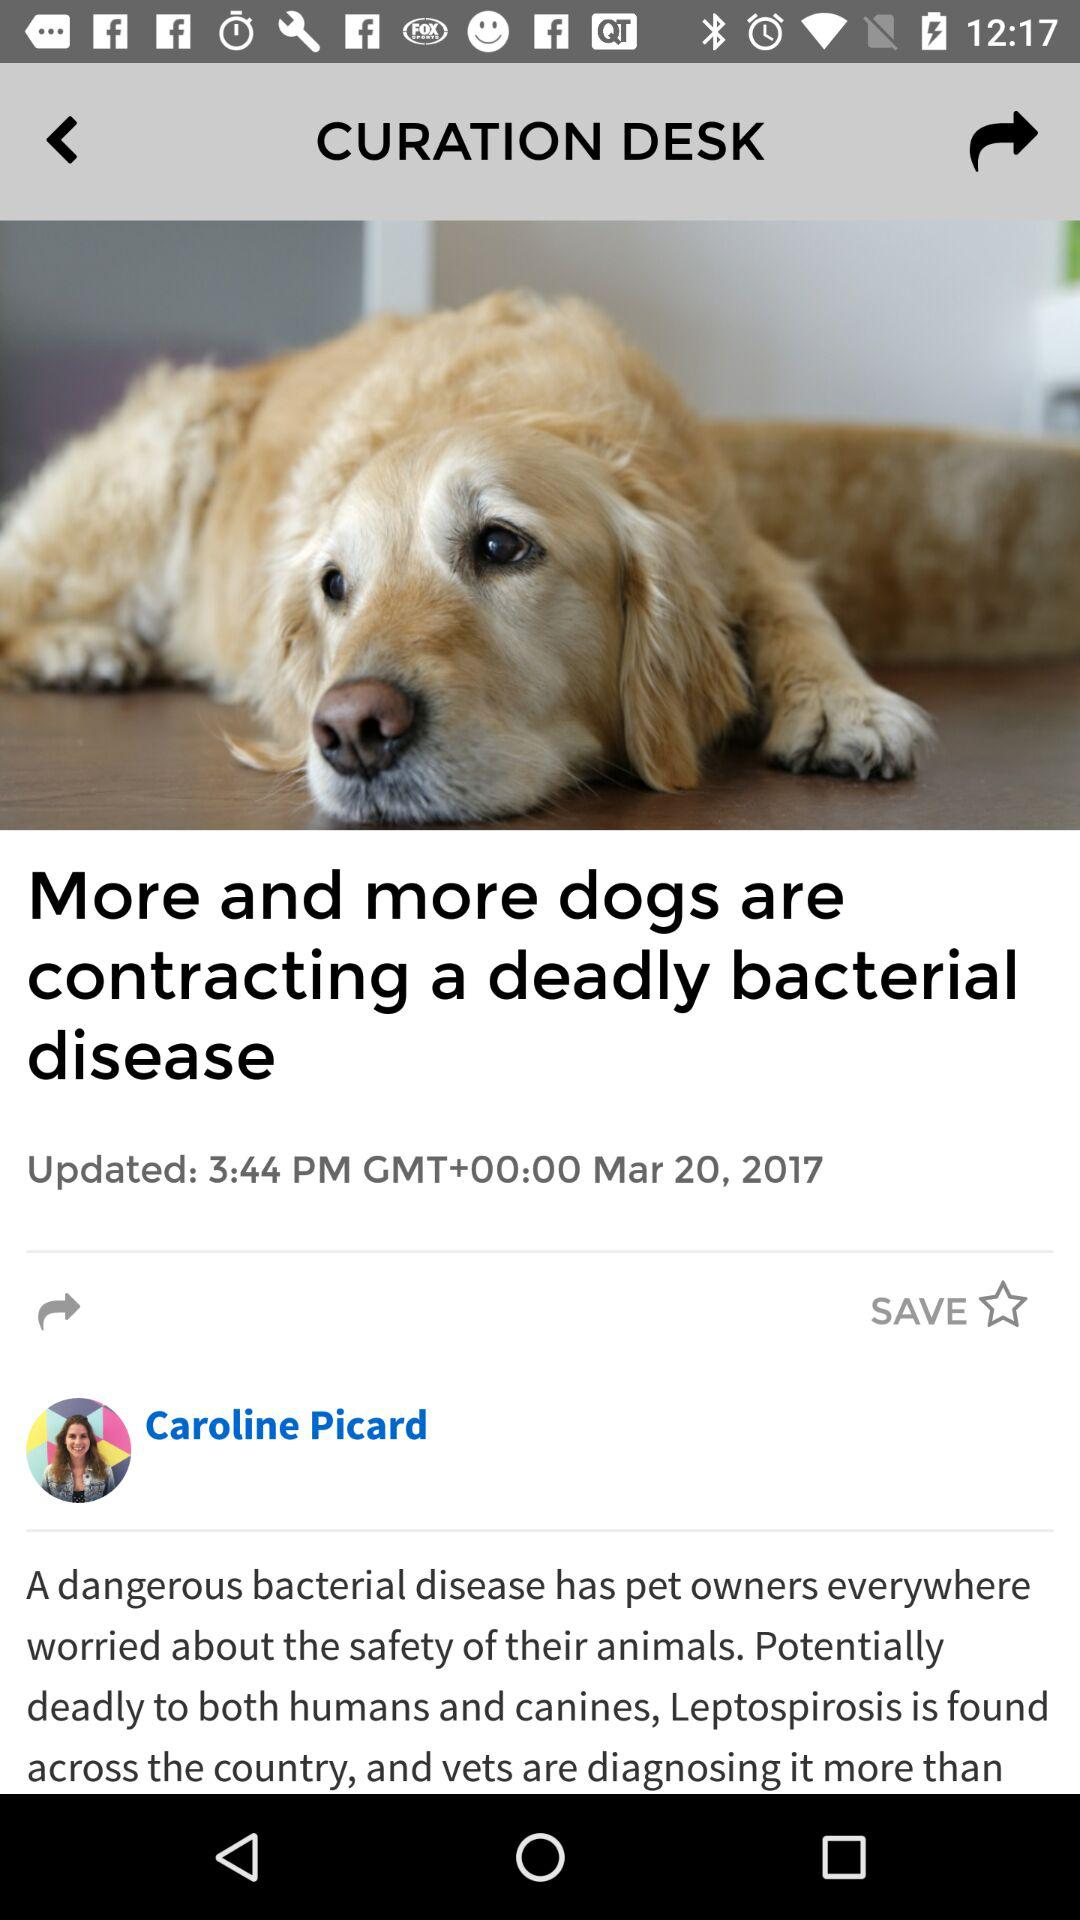What is the name of the author? The author is Caroline Picard. 